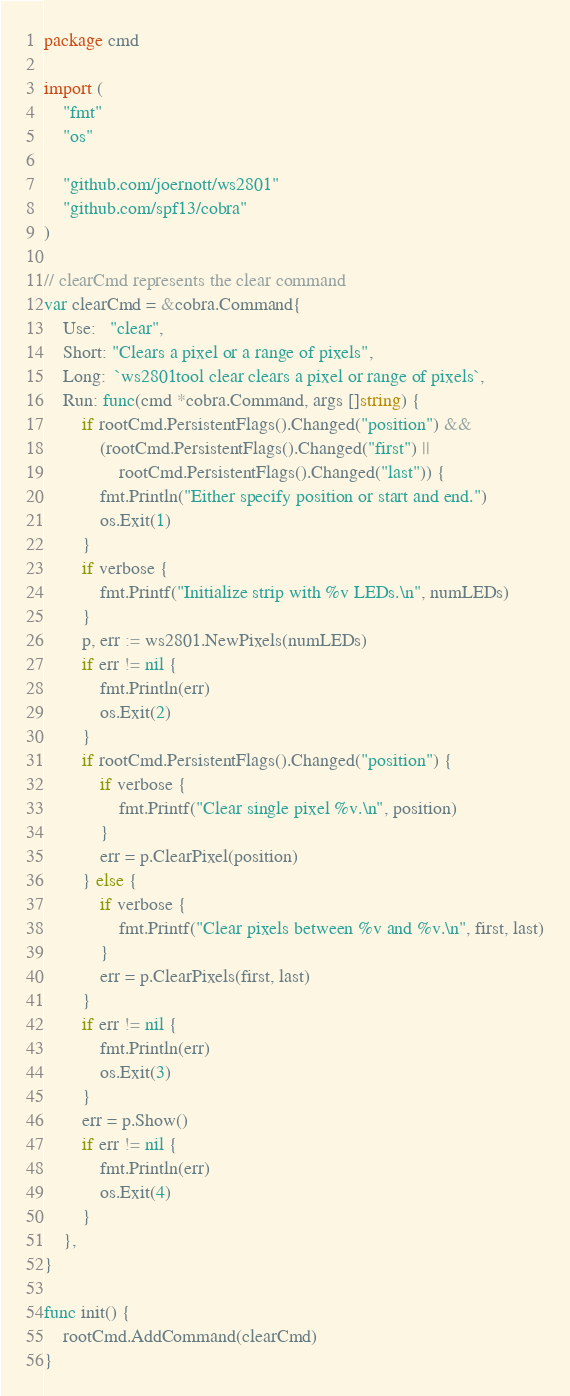Convert code to text. <code><loc_0><loc_0><loc_500><loc_500><_Go_>package cmd

import (
	"fmt"
	"os"

	"github.com/joernott/ws2801"
	"github.com/spf13/cobra"
)

// clearCmd represents the clear command
var clearCmd = &cobra.Command{
	Use:   "clear",
	Short: "Clears a pixel or a range of pixels",
	Long:  `ws2801tool clear clears a pixel or range of pixels`,
	Run: func(cmd *cobra.Command, args []string) {
		if rootCmd.PersistentFlags().Changed("position") &&
			(rootCmd.PersistentFlags().Changed("first") ||
				rootCmd.PersistentFlags().Changed("last")) {
			fmt.Println("Either specify position or start and end.")
			os.Exit(1)
		}
		if verbose {
			fmt.Printf("Initialize strip with %v LEDs.\n", numLEDs)
		}
		p, err := ws2801.NewPixels(numLEDs)
		if err != nil {
			fmt.Println(err)
			os.Exit(2)
		}
		if rootCmd.PersistentFlags().Changed("position") {
			if verbose {
				fmt.Printf("Clear single pixel %v.\n", position)
			}
			err = p.ClearPixel(position)
		} else {
			if verbose {
				fmt.Printf("Clear pixels between %v and %v.\n", first, last)
			}
			err = p.ClearPixels(first, last)
		}
		if err != nil {
			fmt.Println(err)
			os.Exit(3)
		}
		err = p.Show()
		if err != nil {
			fmt.Println(err)
			os.Exit(4)
		}
	},
}

func init() {
	rootCmd.AddCommand(clearCmd)
}
</code> 